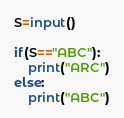Convert code to text. <code><loc_0><loc_0><loc_500><loc_500><_Python_>S=input()

if(S=="ABC"):
    print("ARC")
else:
    print("ABC")
</code> 